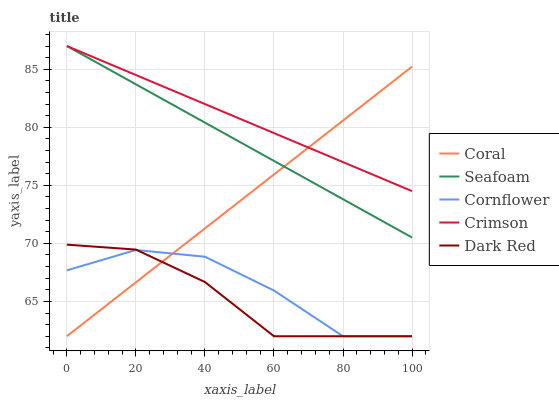Does Cornflower have the minimum area under the curve?
Answer yes or no. No. Does Cornflower have the maximum area under the curve?
Answer yes or no. No. Is Cornflower the smoothest?
Answer yes or no. No. Is Coral the roughest?
Answer yes or no. No. Does Seafoam have the lowest value?
Answer yes or no. No. Does Coral have the highest value?
Answer yes or no. No. Is Cornflower less than Crimson?
Answer yes or no. Yes. Is Seafoam greater than Cornflower?
Answer yes or no. Yes. Does Cornflower intersect Crimson?
Answer yes or no. No. 